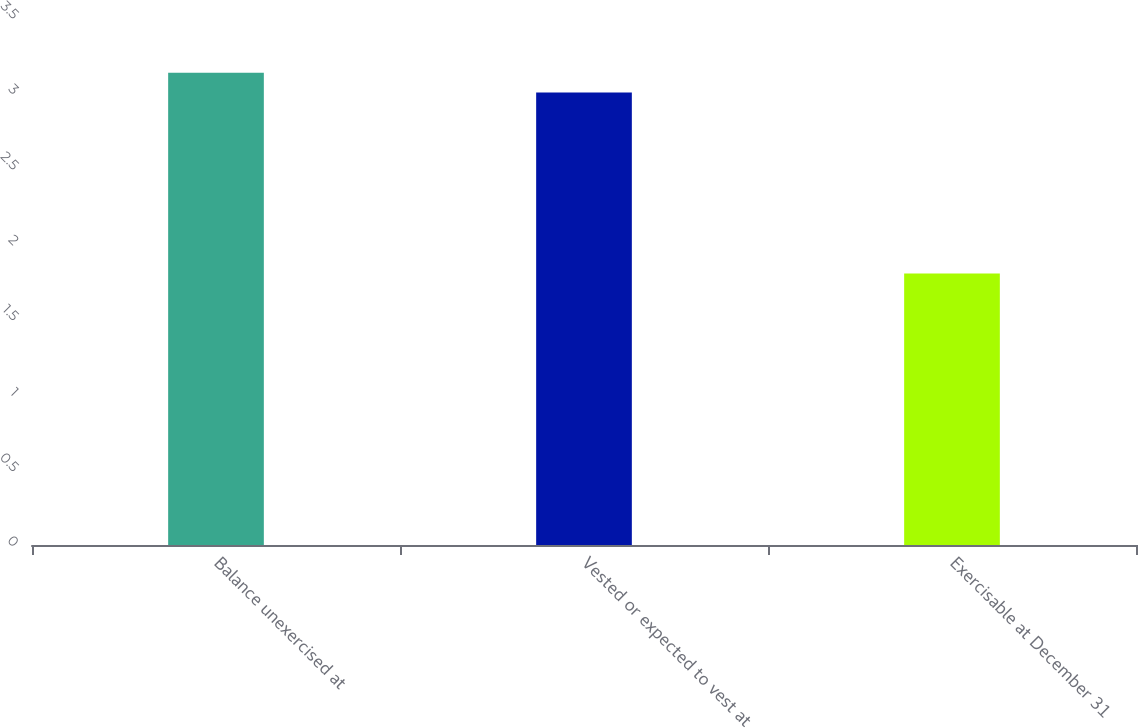<chart> <loc_0><loc_0><loc_500><loc_500><bar_chart><fcel>Balance unexercised at<fcel>Vested or expected to vest at<fcel>Exercisable at December 31<nl><fcel>3.13<fcel>3<fcel>1.8<nl></chart> 